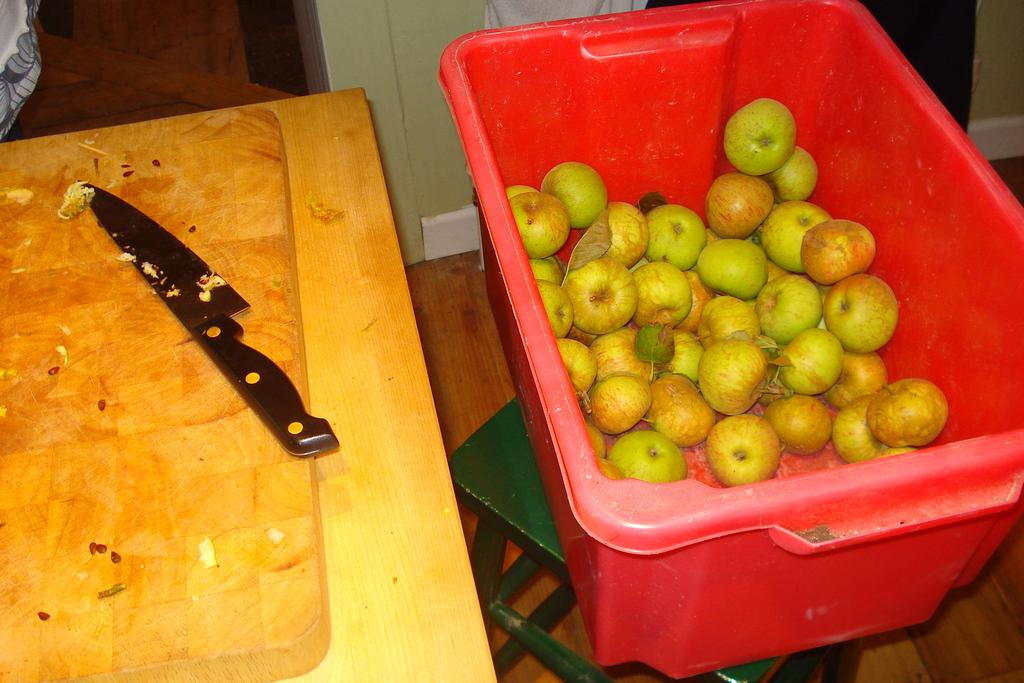What type of fruit is in the container in the image? There are apples in a red container in the image. Where is the container placed? The container is placed on a stool. What can be seen on the wooden surface in the image? There is a knife on a wooden surface in the image. What part of the environment is visible in the image? The ground is visible in the image. What type of hole can be seen in the image? There is no hole present in the image. What view can be seen from the tub in the image? There is no tub present in the image. 